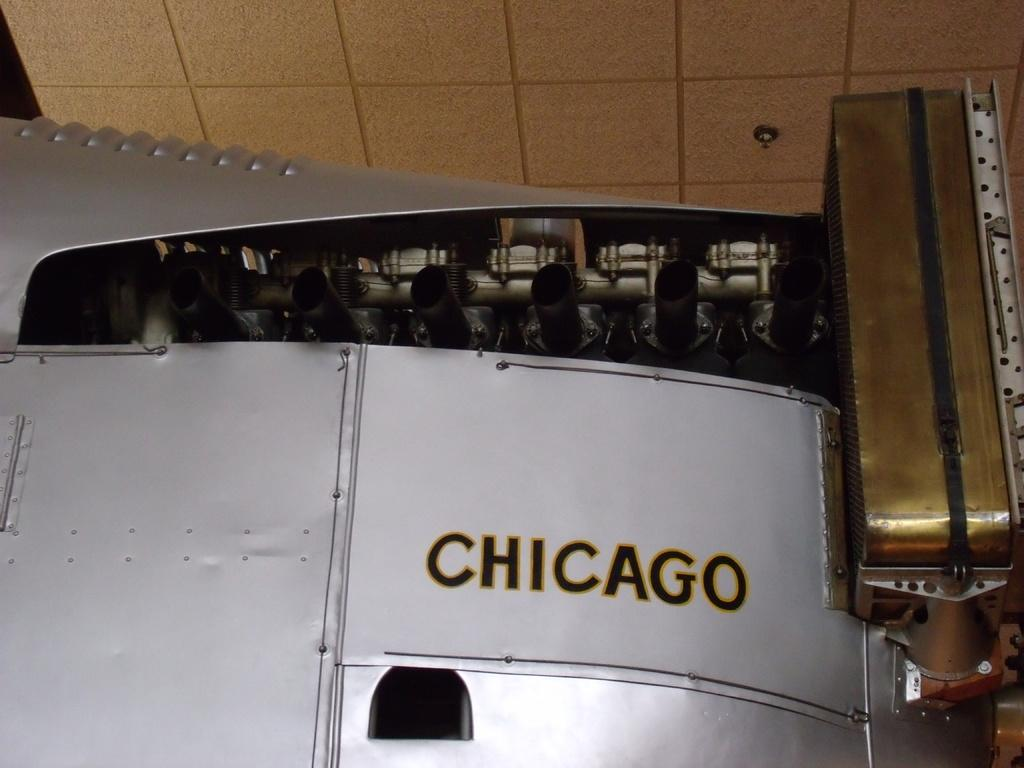<image>
Present a compact description of the photo's key features. Silver wall that has the word Chicago in blac. 